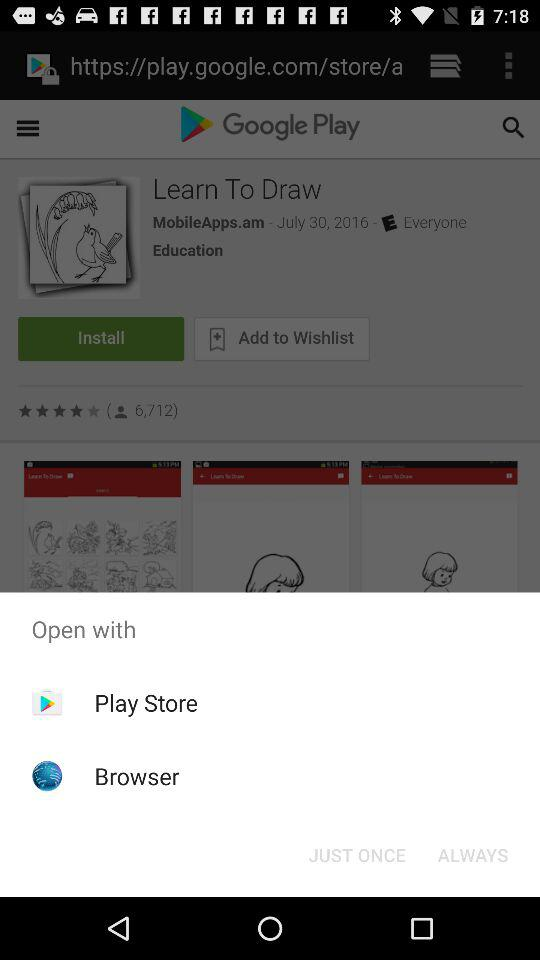When was the other application posted and by whom? The other application was posted on July 30, 2016 and by "Everyone". 